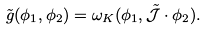Convert formula to latex. <formula><loc_0><loc_0><loc_500><loc_500>\tilde { g } ( \phi _ { 1 } , \phi _ { 2 } ) = \omega _ { K } ( \phi _ { 1 } , \tilde { \mathcal { J } } \cdot \phi _ { 2 } ) .</formula> 